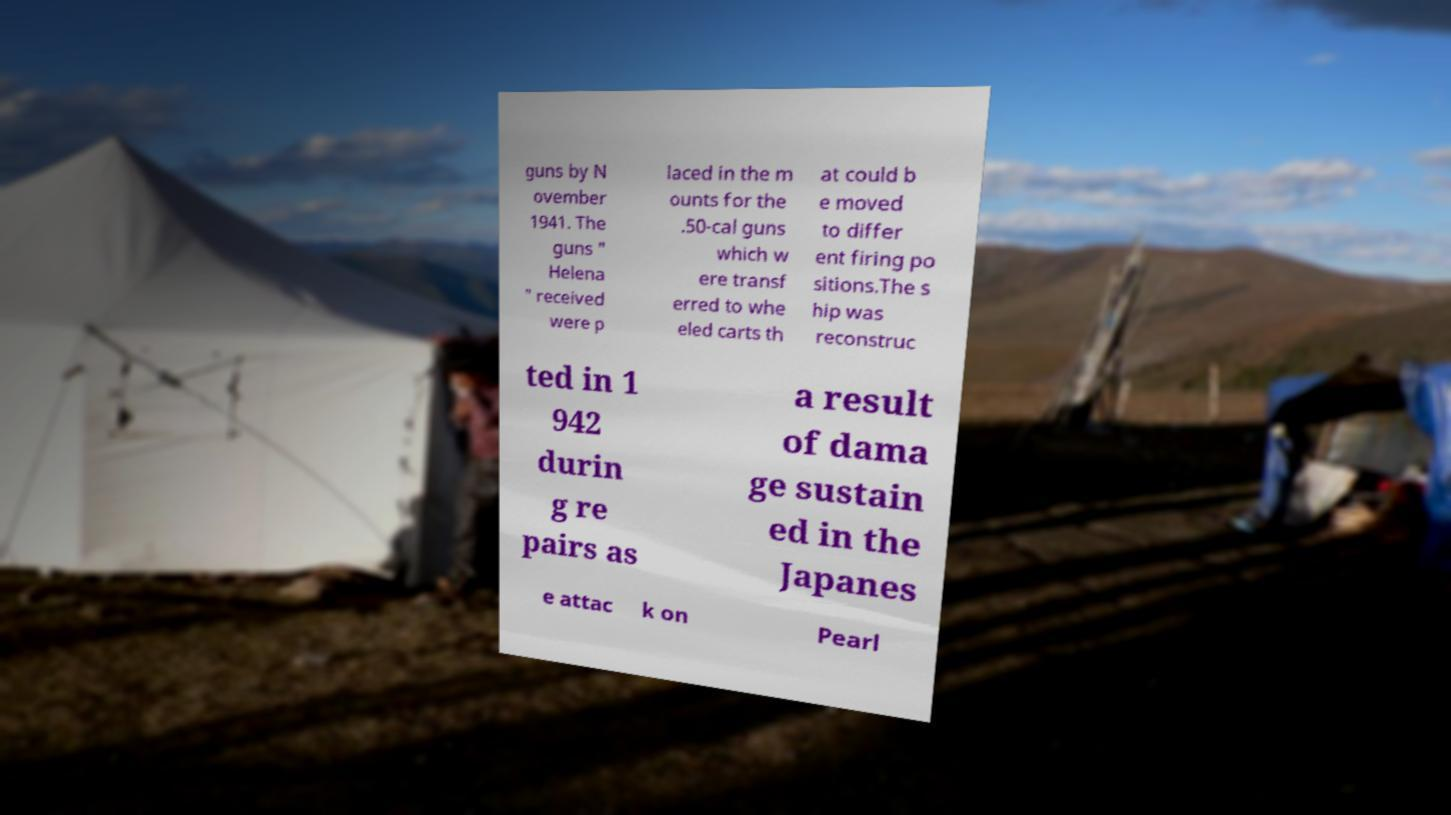There's text embedded in this image that I need extracted. Can you transcribe it verbatim? guns by N ovember 1941. The guns " Helena " received were p laced in the m ounts for the .50-cal guns which w ere transf erred to whe eled carts th at could b e moved to differ ent firing po sitions.The s hip was reconstruc ted in 1 942 durin g re pairs as a result of dama ge sustain ed in the Japanes e attac k on Pearl 